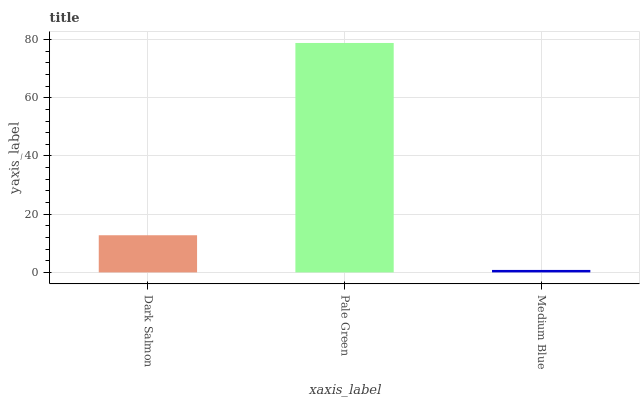Is Medium Blue the minimum?
Answer yes or no. Yes. Is Pale Green the maximum?
Answer yes or no. Yes. Is Pale Green the minimum?
Answer yes or no. No. Is Medium Blue the maximum?
Answer yes or no. No. Is Pale Green greater than Medium Blue?
Answer yes or no. Yes. Is Medium Blue less than Pale Green?
Answer yes or no. Yes. Is Medium Blue greater than Pale Green?
Answer yes or no. No. Is Pale Green less than Medium Blue?
Answer yes or no. No. Is Dark Salmon the high median?
Answer yes or no. Yes. Is Dark Salmon the low median?
Answer yes or no. Yes. Is Pale Green the high median?
Answer yes or no. No. Is Medium Blue the low median?
Answer yes or no. No. 